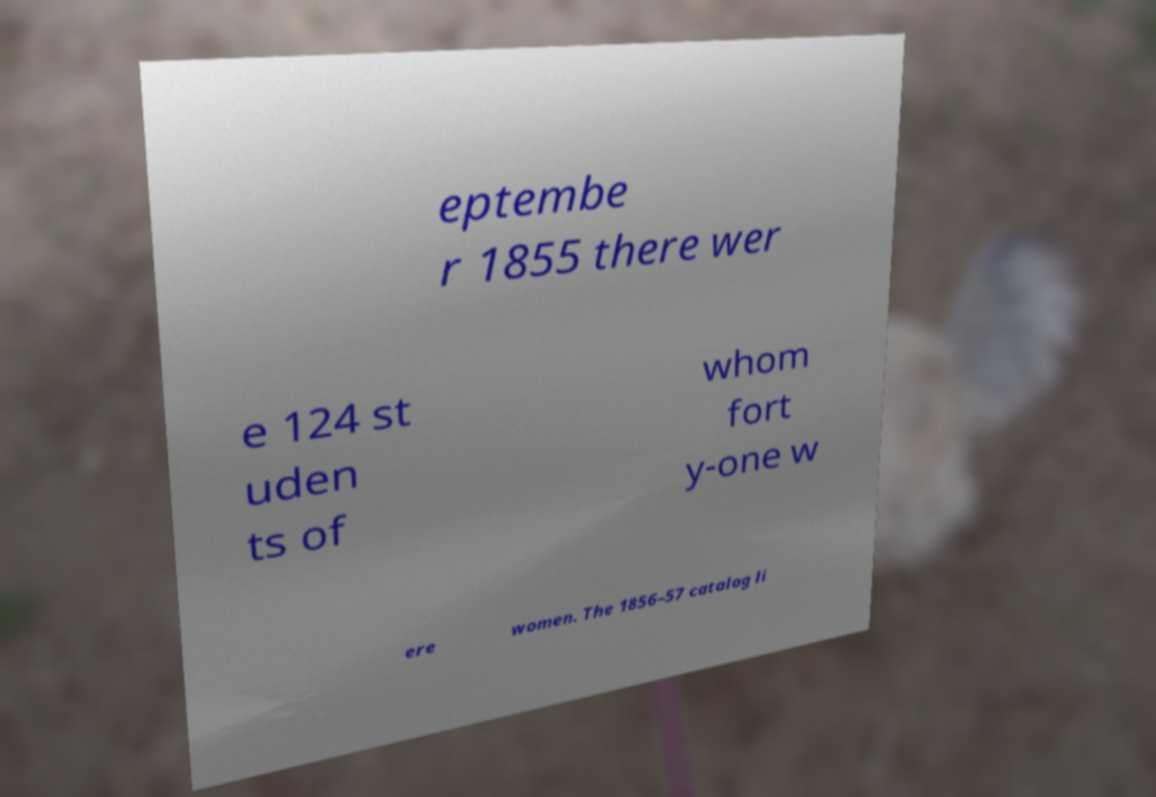For documentation purposes, I need the text within this image transcribed. Could you provide that? eptembe r 1855 there wer e 124 st uden ts of whom fort y-one w ere women. The 1856–57 catalog li 